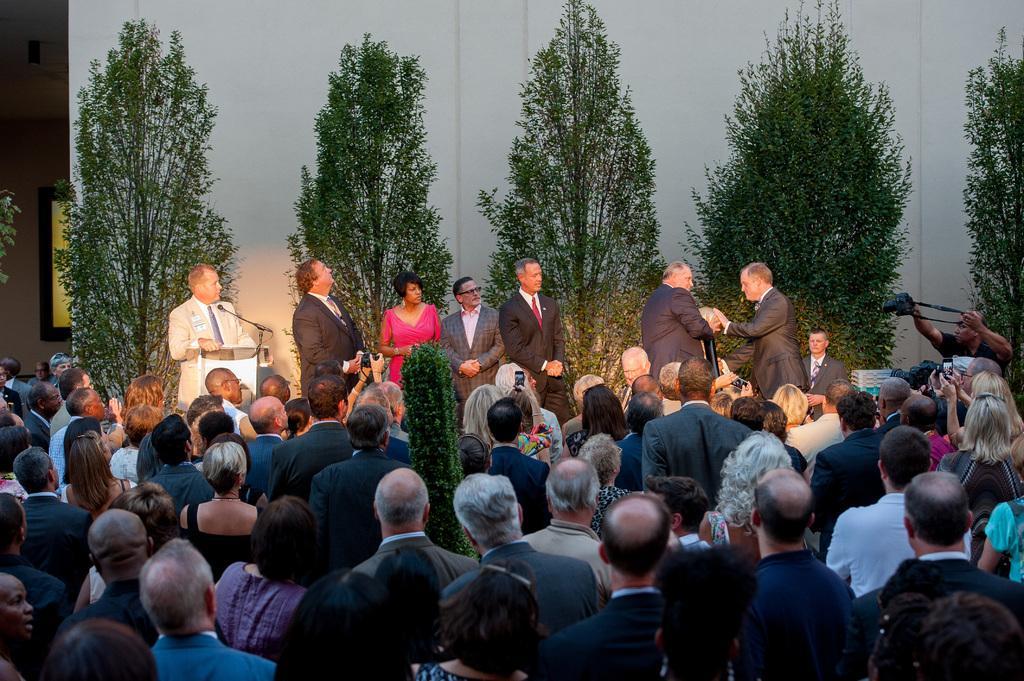Please provide a concise description of this image. In this image I can see group of people standing, in front the person is wearing gray color blazer and the person at left wearing pink color dress, I can also see a camera, a microphone. Background I can see trees in green color and the wall is in white color. 